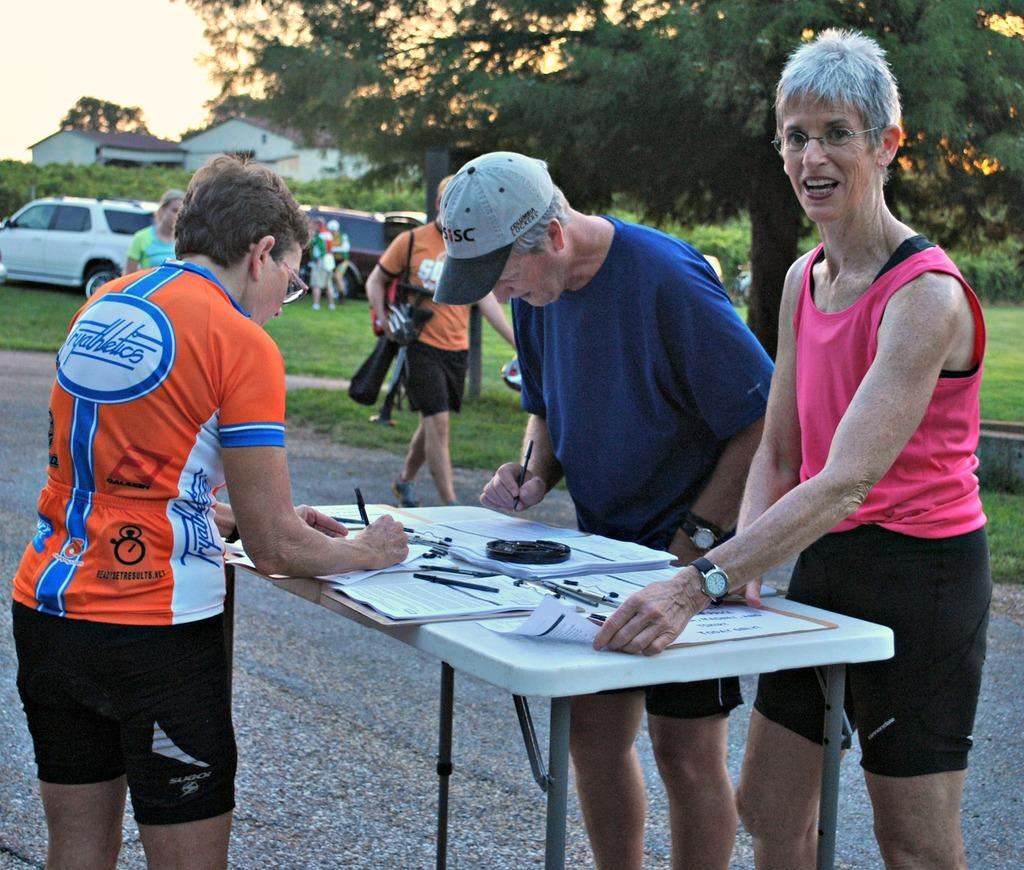What are the people in the image doing? The group of people is standing on the road. What is in front of the group of people? There is a table in front of the group of people. What can be seen on the table? There are objects on the table. What natural element is visible in the image? There is a tree visible in the image. What type of structure is present in the image? There is a house in the image. What type of drum is being played by the owner of the house in the image? There is no drum or owner of the house present in the image. 